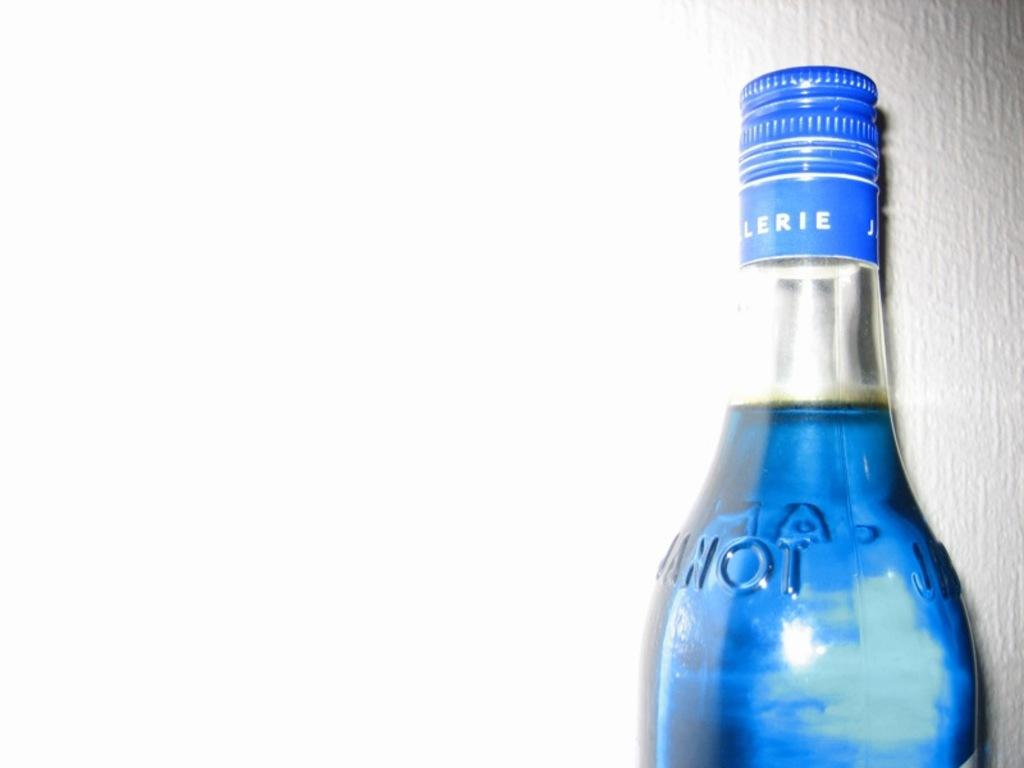<image>
Offer a succinct explanation of the picture presented. A bottle with a blue top with LERIE written on it. 